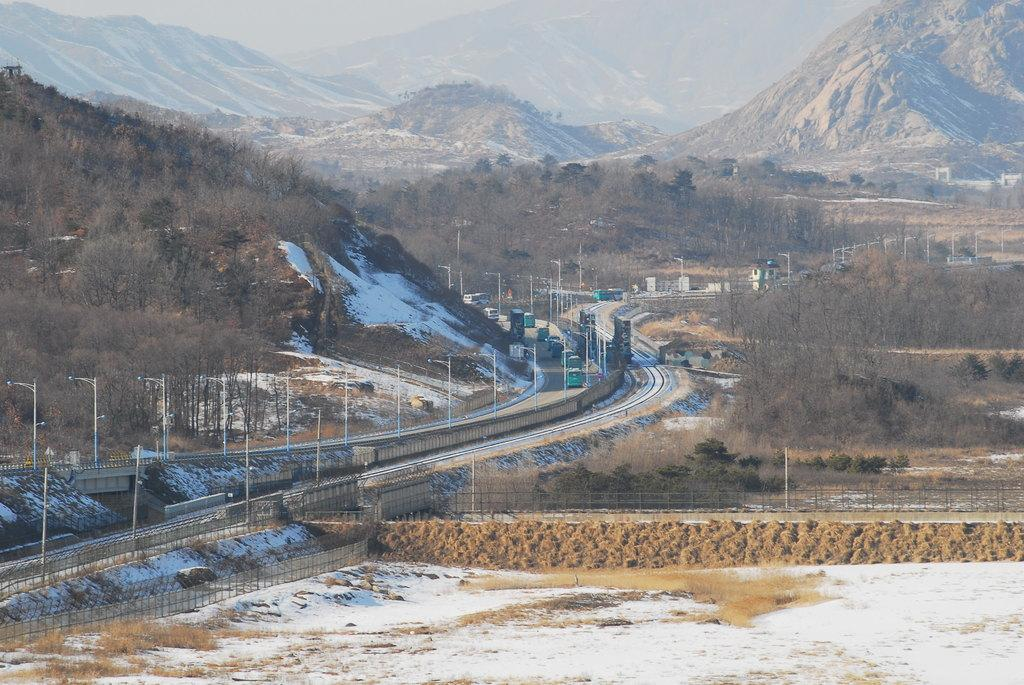What can be seen running through the image? There is a path in the image. What types of transportation are present in the image? There are vehicles in the image. What structures can be seen in the image? There are poles in the image. What type of vegetation is present in the image? There are trees in the image. What weather condition is depicted in the image? There is white snow visible in the image. What geographical feature can be seen in the background of the image? There are mountains in the background of the image. What type of rhythm can be heard coming from the mountains in the image? There is no sound or rhythm present in the image; it is a still image. How many brothers are visible in the image? There are no people, let alone brothers, present in the image. 